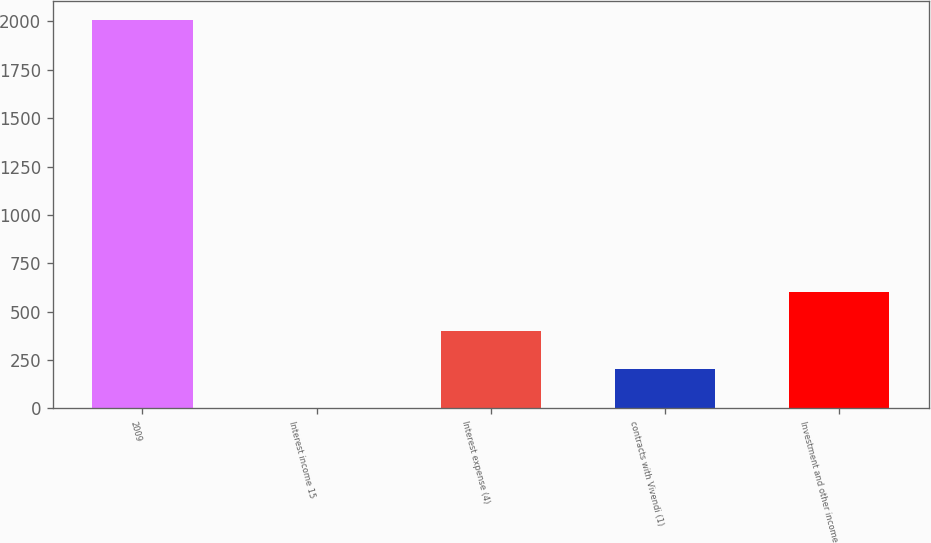Convert chart. <chart><loc_0><loc_0><loc_500><loc_500><bar_chart><fcel>2009<fcel>Interest income 15<fcel>Interest expense (4)<fcel>contracts with Vivendi (1)<fcel>Investment and other income<nl><fcel>2007<fcel>1<fcel>402.2<fcel>201.6<fcel>602.8<nl></chart> 